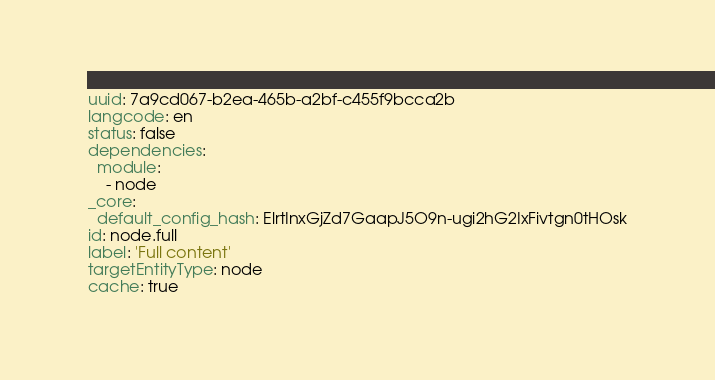Convert code to text. <code><loc_0><loc_0><loc_500><loc_500><_YAML_>uuid: 7a9cd067-b2ea-465b-a2bf-c455f9bcca2b
langcode: en
status: false
dependencies:
  module:
    - node
_core:
  default_config_hash: ElrtInxGjZd7GaapJ5O9n-ugi2hG2IxFivtgn0tHOsk
id: node.full
label: 'Full content'
targetEntityType: node
cache: true
</code> 